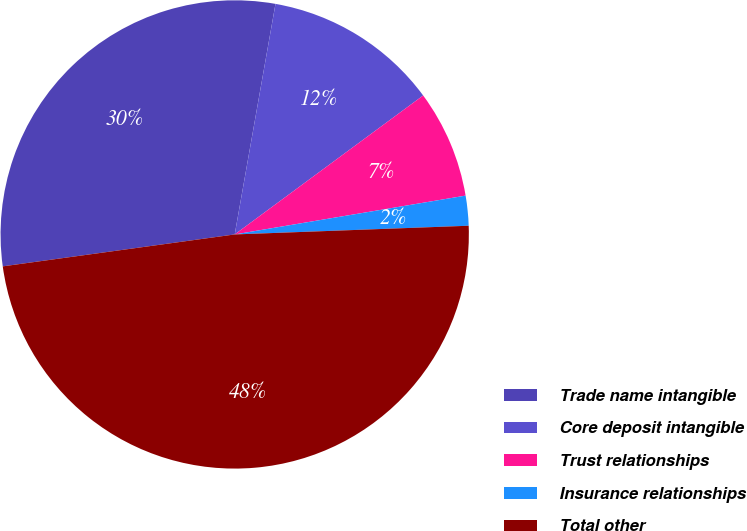Convert chart. <chart><loc_0><loc_0><loc_500><loc_500><pie_chart><fcel>Trade name intangible<fcel>Core deposit intangible<fcel>Trust relationships<fcel>Insurance relationships<fcel>Total other<nl><fcel>29.96%<fcel>12.1%<fcel>7.46%<fcel>2.06%<fcel>48.41%<nl></chart> 